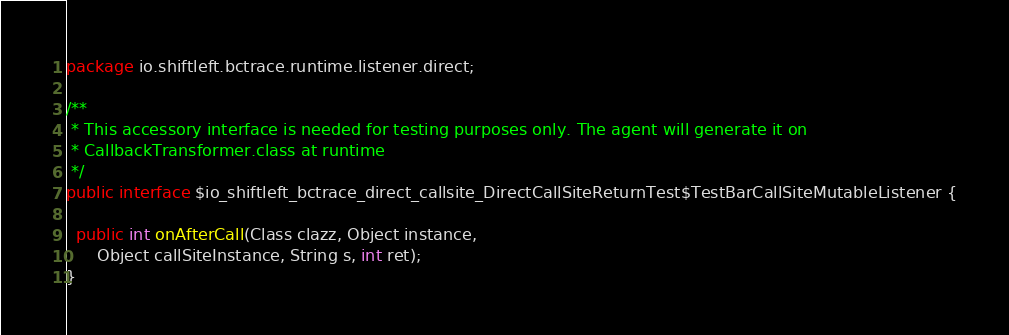<code> <loc_0><loc_0><loc_500><loc_500><_Java_>package io.shiftleft.bctrace.runtime.listener.direct;

/**
 * This accessory interface is needed for testing purposes only. The agent will generate it on
 * CallbackTransformer.class at runtime
 */
public interface $io_shiftleft_bctrace_direct_callsite_DirectCallSiteReturnTest$TestBarCallSiteMutableListener {

  public int onAfterCall(Class clazz, Object instance,
      Object callSiteInstance, String s, int ret);
}
</code> 